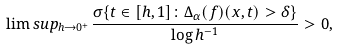Convert formula to latex. <formula><loc_0><loc_0><loc_500><loc_500>\lim s u p _ { h \to 0 ^ { + } } \frac { \sigma \{ t \in [ h , 1 ] \colon \Delta _ { \alpha } ( f ) ( x , t ) > \delta \} } { \log { h } ^ { - 1 } } > 0 ,</formula> 